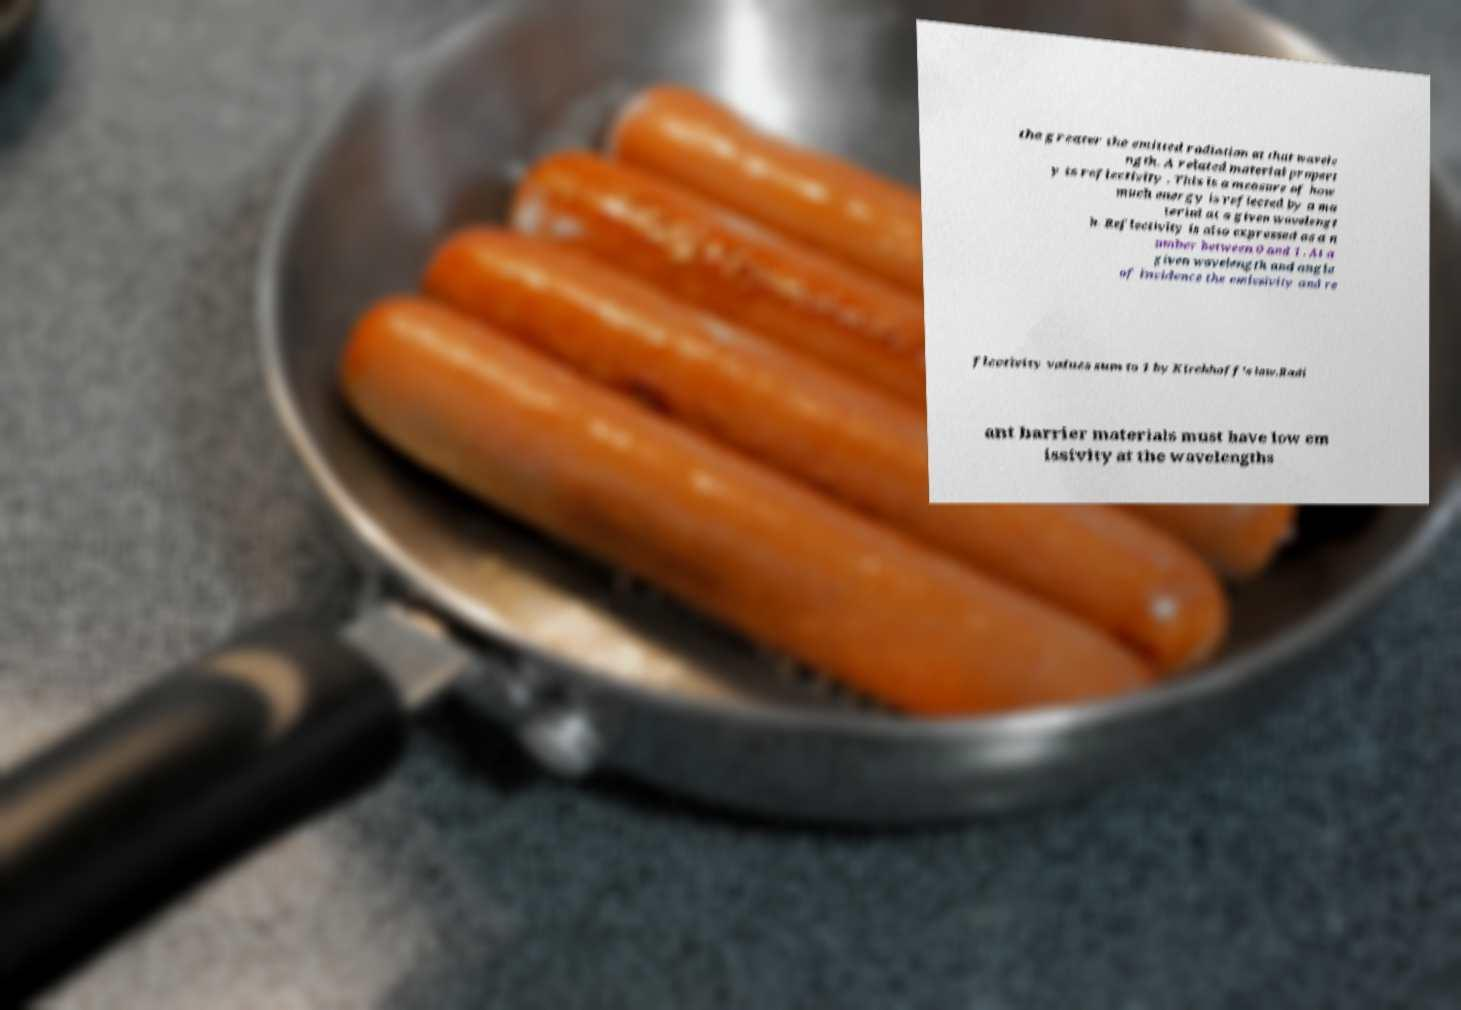Could you extract and type out the text from this image? the greater the emitted radiation at that wavele ngth. A related material propert y is reflectivity . This is a measure of how much energy is reflected by a ma terial at a given wavelengt h. Reflectivity is also expressed as a n umber between 0 and 1 . At a given wavelength and angle of incidence the emissivity and re flectivity values sum to 1 by Kirchhoff's law.Radi ant barrier materials must have low em issivity at the wavelengths 